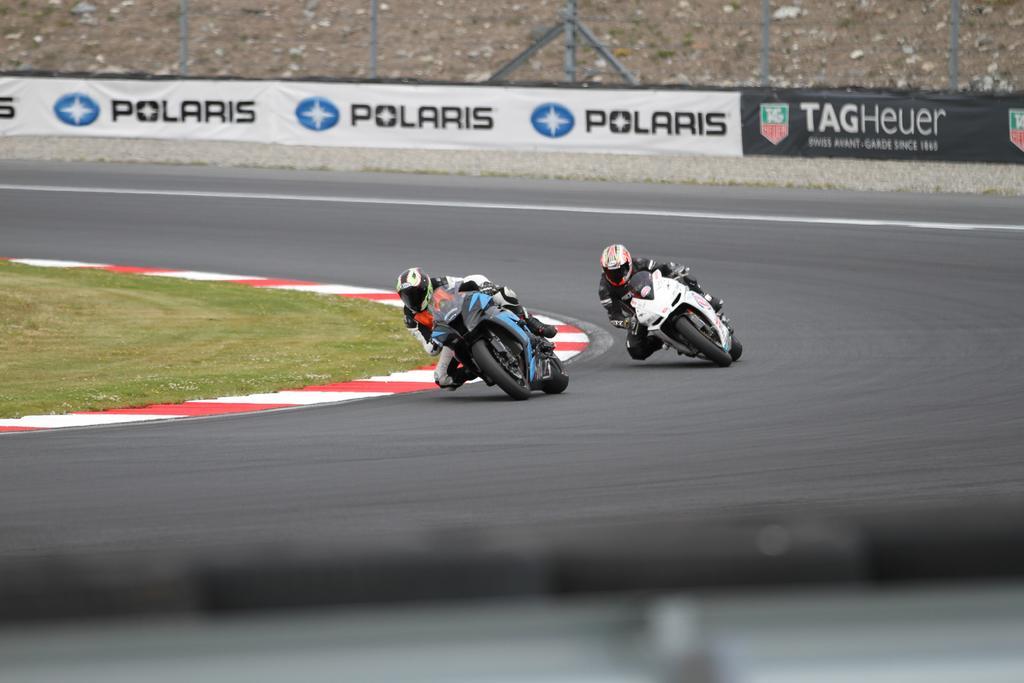How would you summarize this image in a sentence or two? In this image I can see a road and 2 bikes on it. I can see two people riding two different bikes. In the background I can see banner. 